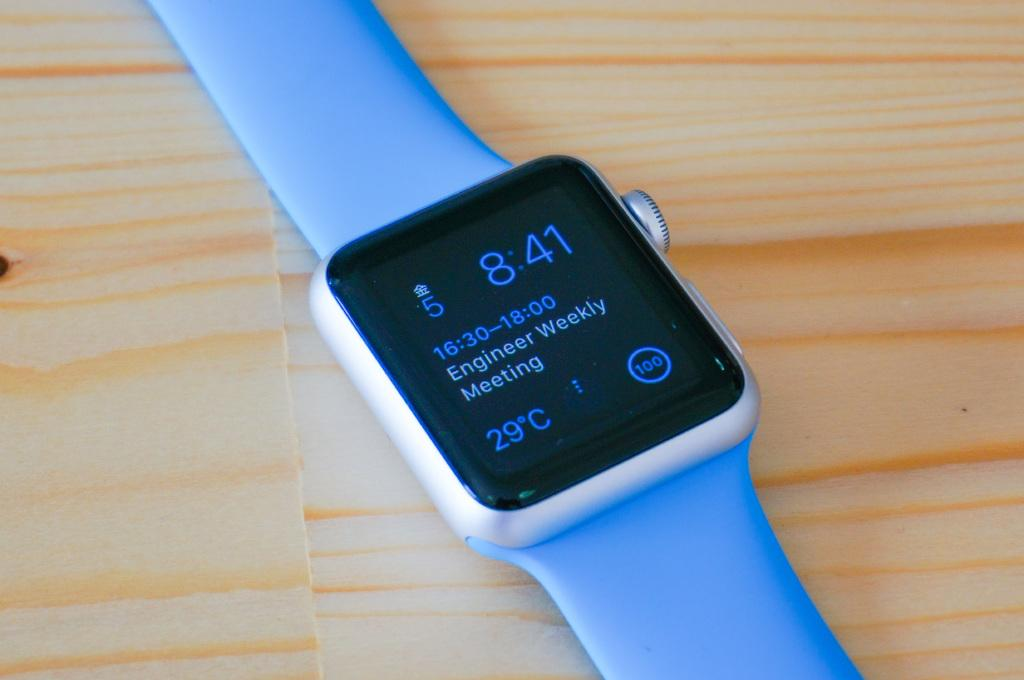Provide a one-sentence caption for the provided image. A smart watch shows a meeting notification among other pieces of information. 